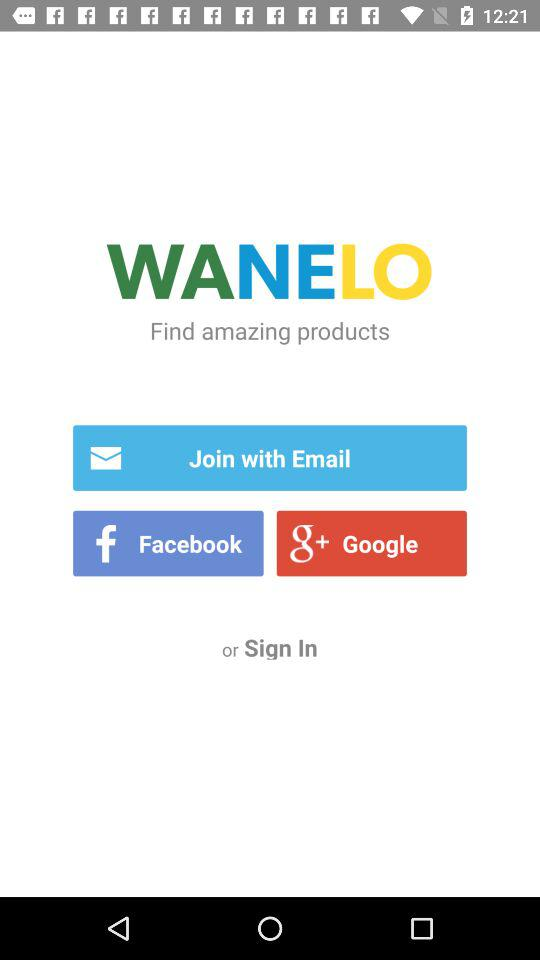From which app we can share?
When the provided information is insufficient, respond with <no answer>. <no answer> 